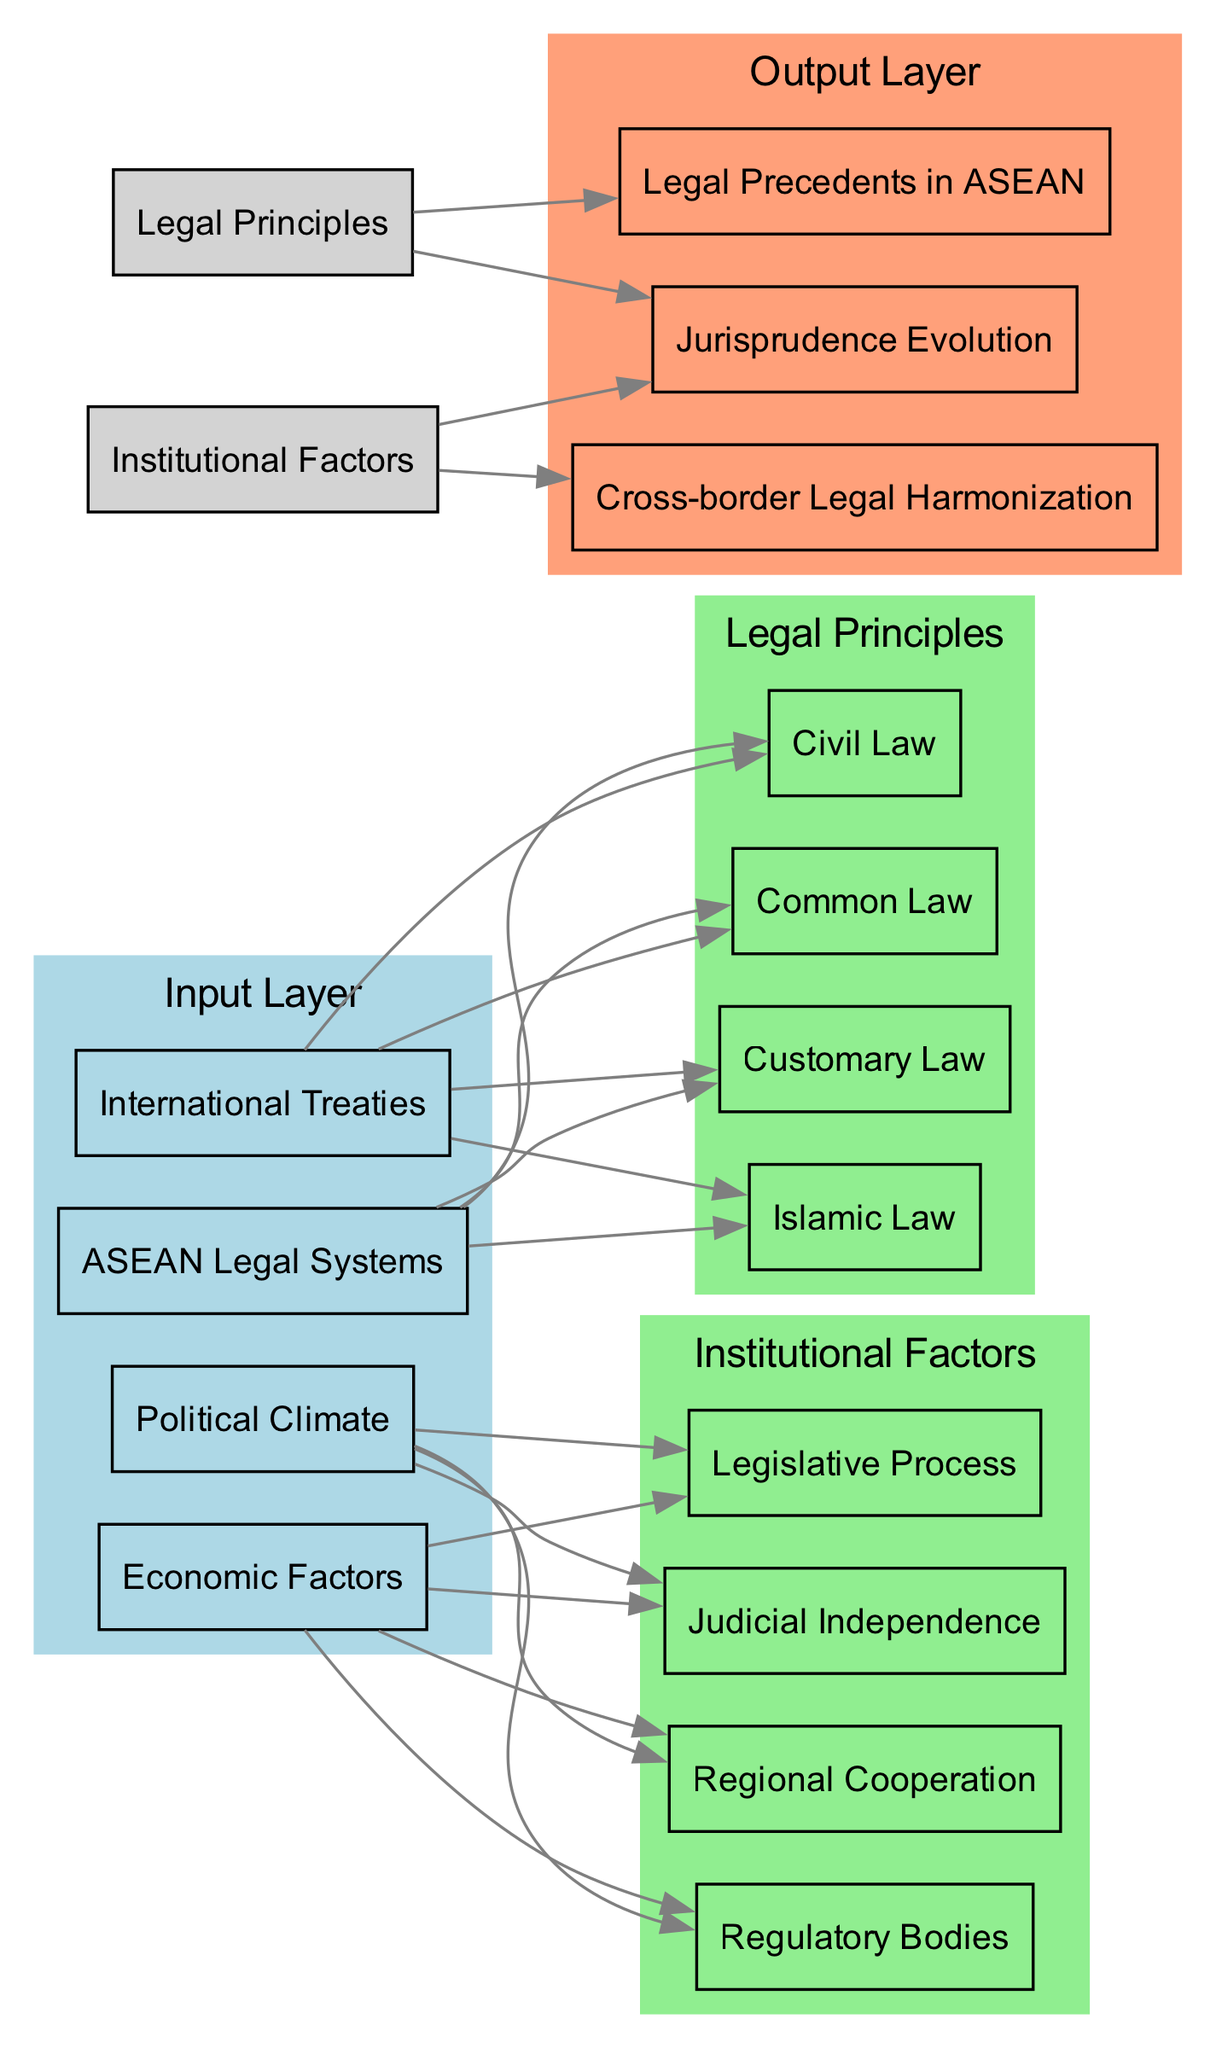What are the input nodes in the diagram? The input nodes are explicitly listed in the diagram’s input layer section, which includes "ASEAN Legal Systems", "Political Climate", "Economic Factors", and "International Treaties".
Answer: ASEAN Legal Systems, Political Climate, Economic Factors, International Treaties How many hidden layers does the diagram have? The diagram contains two hidden layers as seen in the structure labeled 'Legal Principles' and 'Institutional Factors'.
Answer: 2 Which factor influences "Cross-border Legal Harmonization"? The connection from "Institutional Factors" leading to "Cross-border Legal Harmonization" indicates that this factor is influenced by Institutional Factors.
Answer: Institutional Factors What type of legal principles are included in the hidden layer? The hidden layer titled 'Legal Principles' consists of four types of legal systems: "Common Law", "Civil Law", "Islamic Law", and "Customary Law".
Answer: Common Law, Civil Law, Islamic Law, Customary Law Which input node connects to the "Legal Precedents in ASEAN"? The connection from "Legal Principles" to "Legal Precedents in ASEAN" shows that this output is primarily influenced by the different Legal Principles established in the input nodes.
Answer: Legal Principles If "Political Climate" and "Economic Factors" were to impact "Judicial Independence", which path would they take? Both "Political Climate" and "Economic Factors" have connections to the "Institutional Factors", which in turn leads to "Judicial Independence". Thus, the path is: Political Climate → Institutional Factors → Judicial Independence and Economic Factors → Institutional Factors → Judicial Independence.
Answer: Political Climate → Institutional Factors → Judicial Independence, Economic Factors → Institutional Factors → Judicial Independence Which output node illustrates the relationship between legal principles and their development over time? The output node "Jurisprudence Evolution" depicts how the legal principles contribute to the ongoing development of jurisprudence.
Answer: Jurisprudence Evolution What is the color of the input nodes in the diagram? The input nodes are marked in light blue according to the diagram’s color scheme that assigns colors to different layers.
Answer: Light blue Which node has the most connections? "Legal Principles" has the most connections, as seen by its direct links to both "Legal Precedents in ASEAN" and "Jurisprudence Evolution".
Answer: Legal Principles 